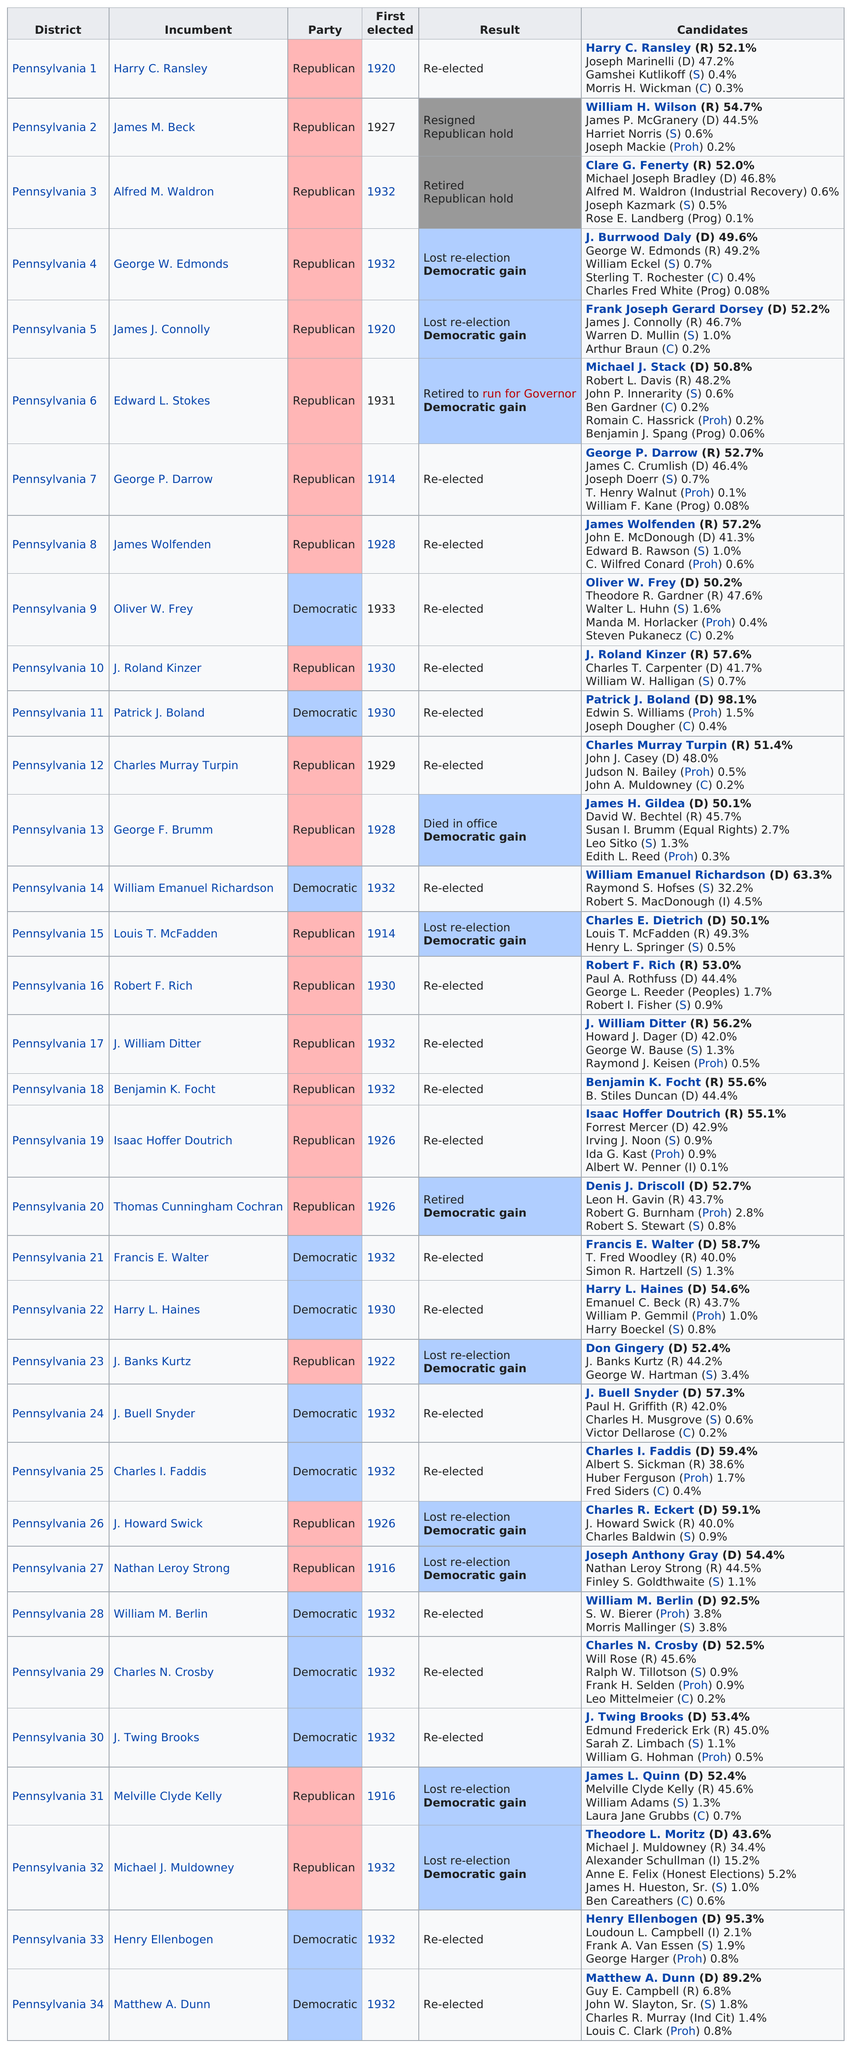List a handful of essential elements in this visual. In the recent elections, 12 democrats were re-elected. According to the data, the highest percentage of votes received by a Republican was 57.6%. Benjamin J. Spang had the least votes by percentage among all candidates. Nine Republicans were re-elected after 1920. The question of who received a higher percentage of votes, Clare G. Fenerty or William H. Wilson, was answered with William H. Wilson having received more votes. 